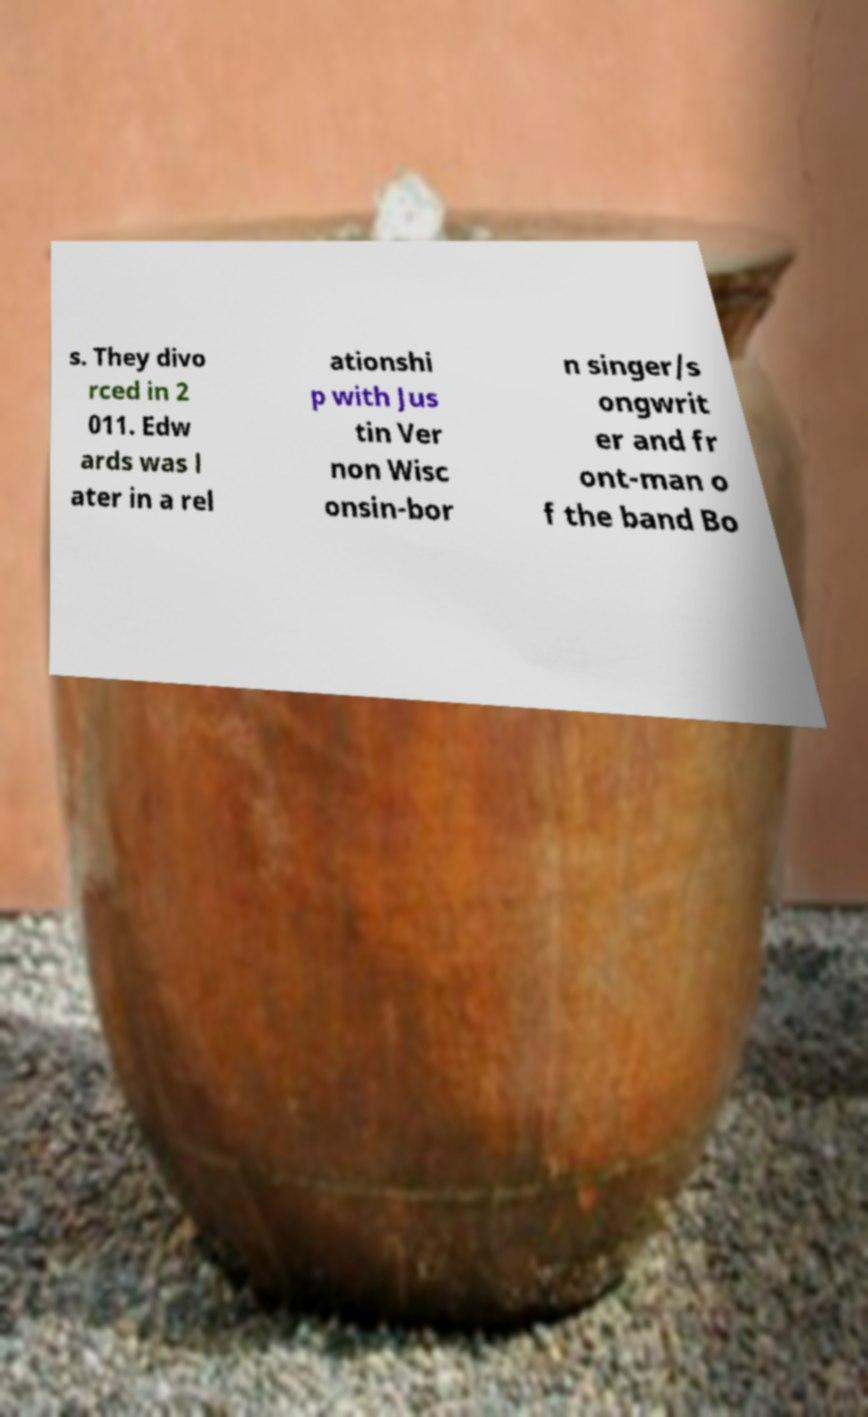There's text embedded in this image that I need extracted. Can you transcribe it verbatim? s. They divo rced in 2 011. Edw ards was l ater in a rel ationshi p with Jus tin Ver non Wisc onsin-bor n singer/s ongwrit er and fr ont-man o f the band Bo 